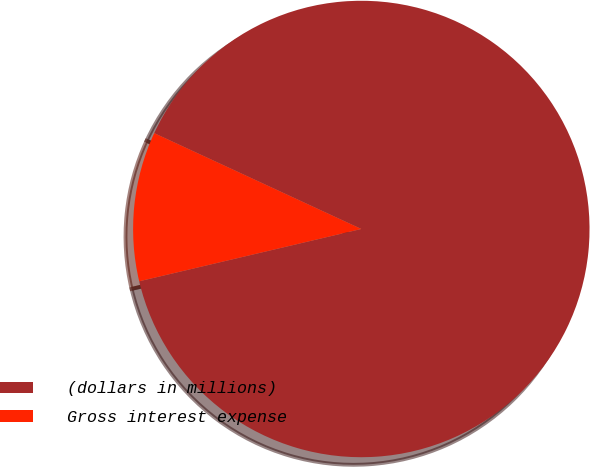Convert chart. <chart><loc_0><loc_0><loc_500><loc_500><pie_chart><fcel>(dollars in millions)<fcel>Gross interest expense<nl><fcel>89.42%<fcel>10.58%<nl></chart> 